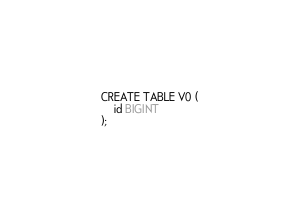<code> <loc_0><loc_0><loc_500><loc_500><_SQL_>CREATE TABLE V0 (
    id BIGINT
);
</code> 